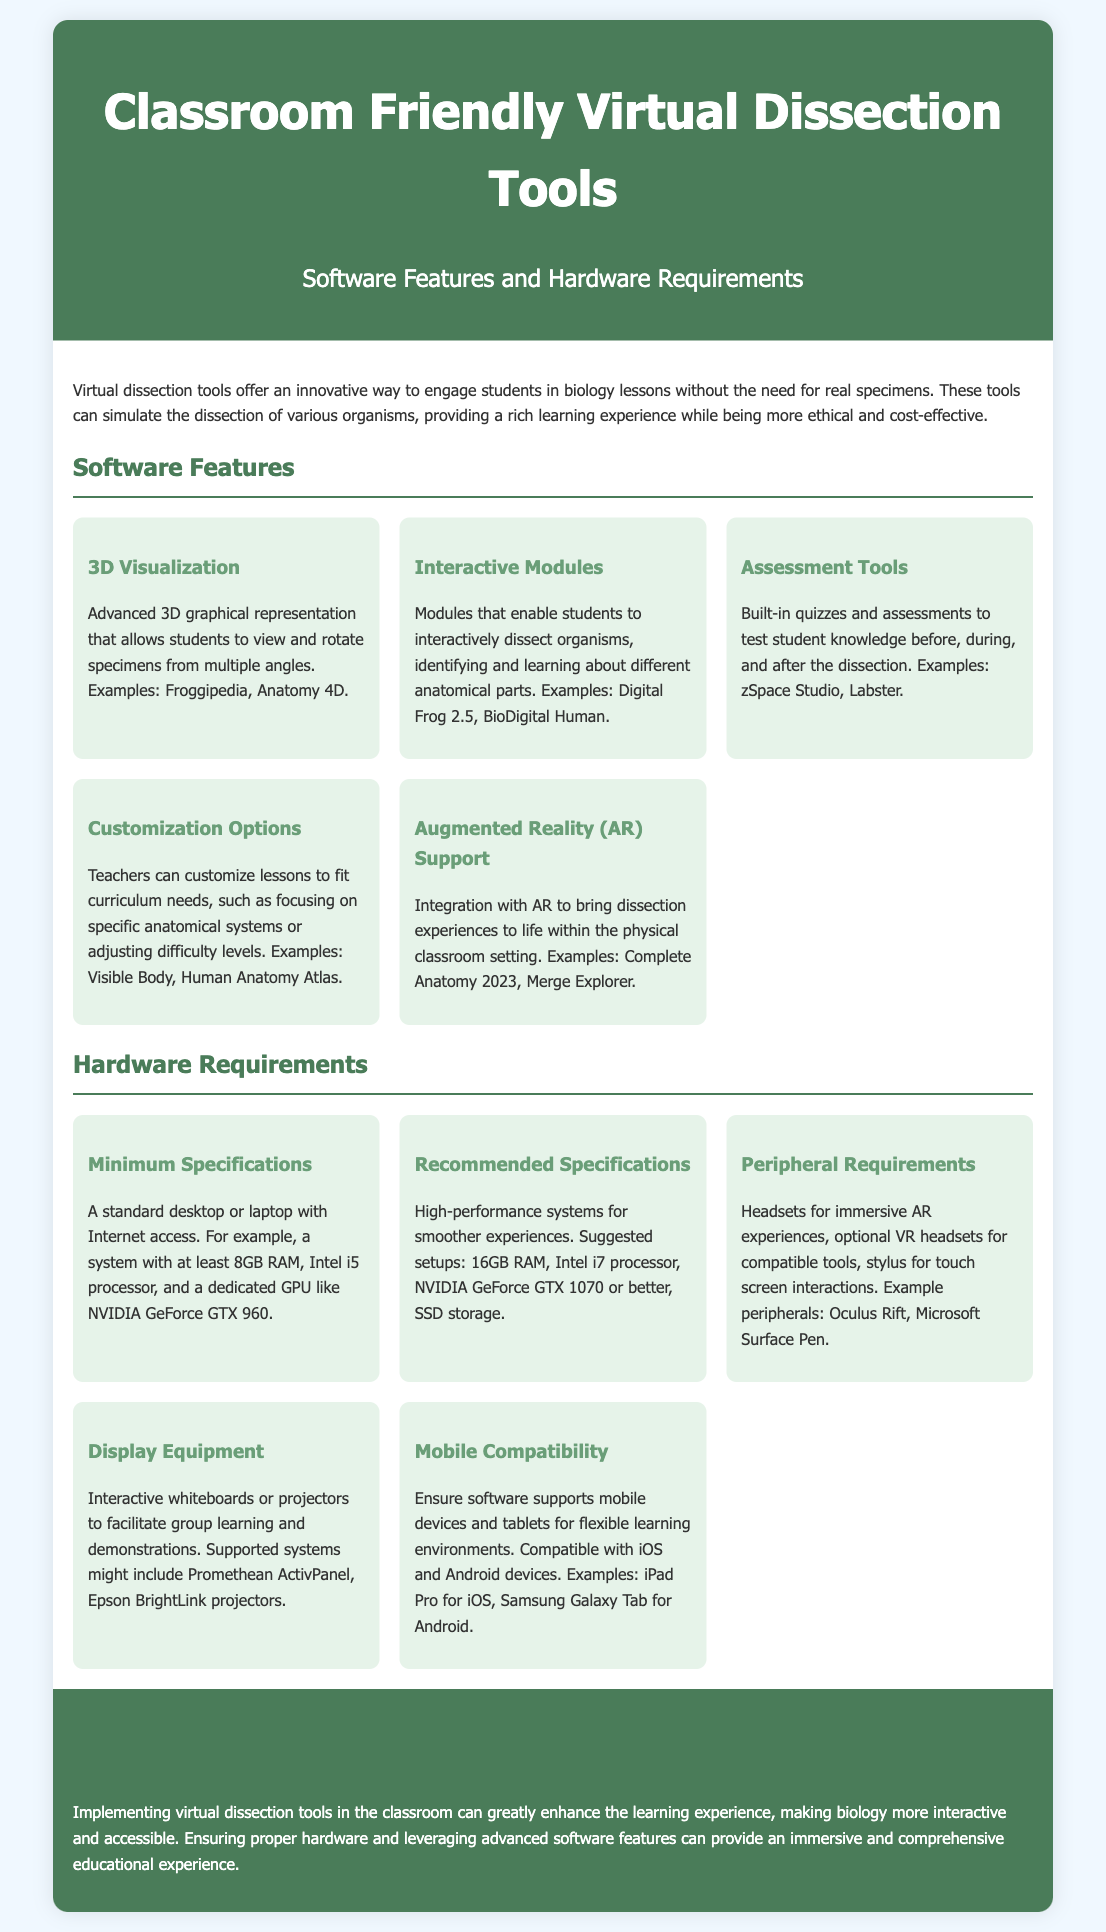what is the title of the document? The title of the document is stated at the top of the page.
Answer: Classroom Friendly Virtual Dissection Tools name one example of a software that provides 3D visualization. The document lists examples of software in each feature section.
Answer: Froggipedia what is the minimum specification for RAM? The minimum specification for RAM is mentioned under the hardware requirements section.
Answer: 8GB how many interactive modules are mentioned in the software features? The document describes various software features, specifically noting one for interactive modules.
Answer: 1 what is the recommended processor for high-performance systems? The recommended specifications detail the required processor for optimal performance.
Answer: Intel i7 name one accessory mentioned under peripheral requirements. Peripherals are listed in the hardware requirements, specifying compatible accessories.
Answer: Oculus Rift what feature allows customization of lessons? The document categorizes features of the software that relate to lesson adaptations.
Answer: Customization Options what type of display equipment is recommended? The recommended display equipment is outlined within the hardware requirements section.
Answer: Interactive whiteboards how does virtual dissection contribute to the learning experience? The conclusion summarizes the benefits of virtual dissection tools for education.
Answer: Enhances interactivity and accessibility 